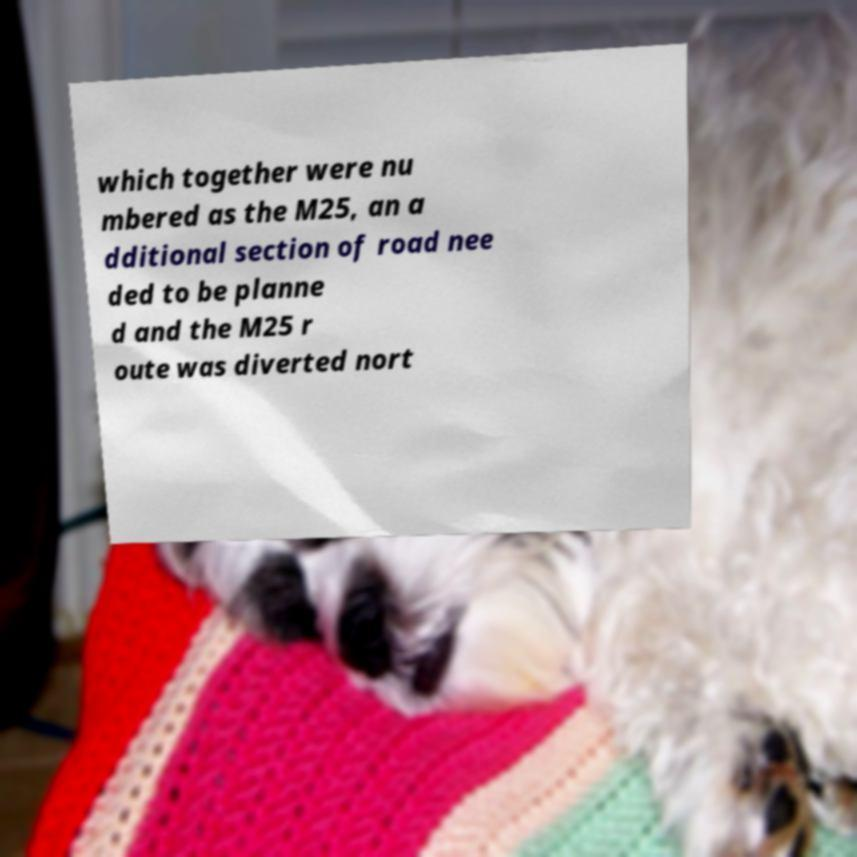Could you assist in decoding the text presented in this image and type it out clearly? which together were nu mbered as the M25, an a dditional section of road nee ded to be planne d and the M25 r oute was diverted nort 